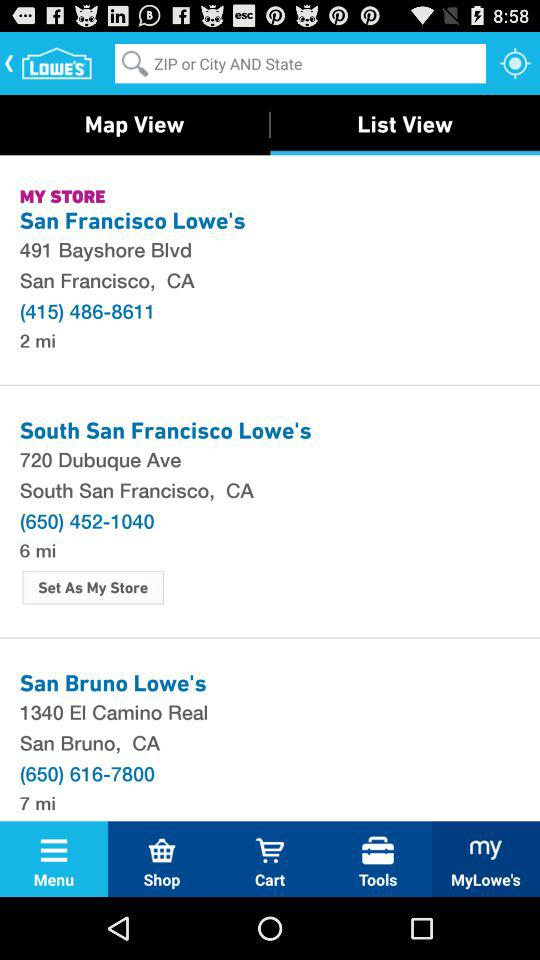How many stores are there in total?
Answer the question using a single word or phrase. 3 